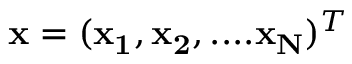Convert formula to latex. <formula><loc_0><loc_0><loc_500><loc_500>{ x } = ( { x _ { 1 } } , { x _ { 2 } } , \cdots { x _ { N } } ) ^ { T }</formula> 